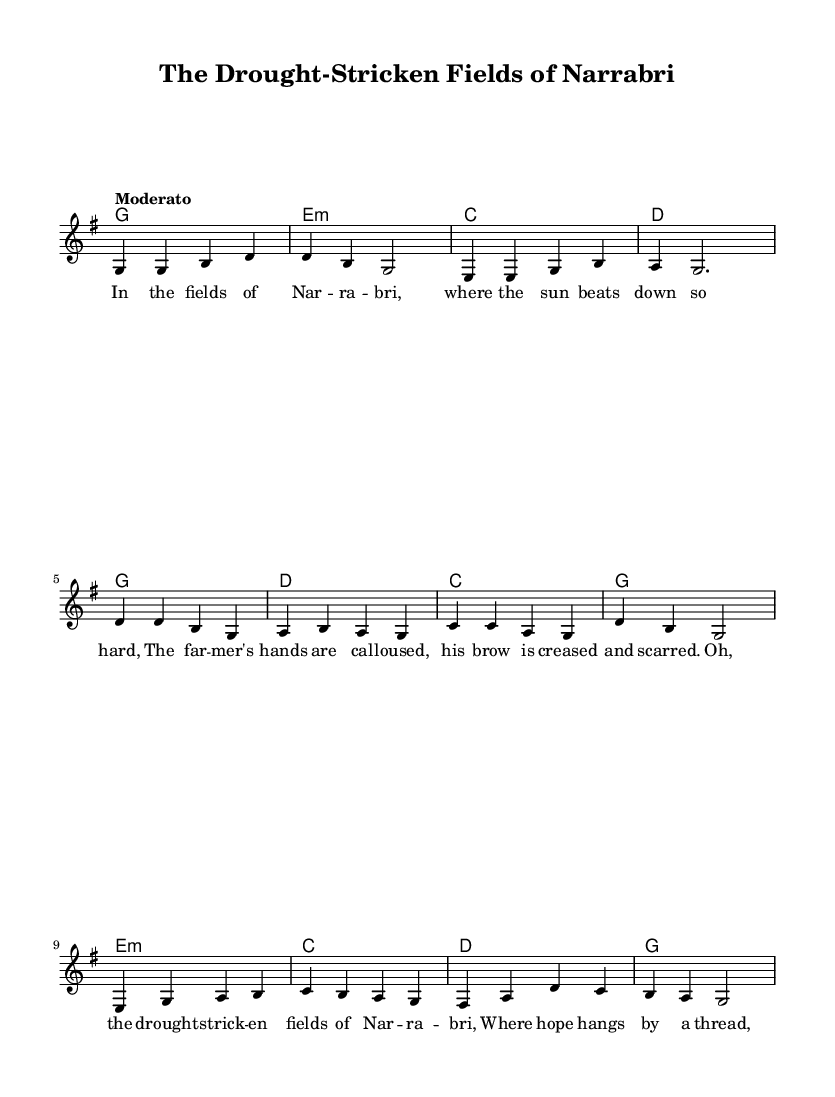What is the key signature of this music? The key signature is G major, which has one sharp (F#). This can be determined by looking at the signature markers at the start of the staff that indicate G major.
Answer: G major What is the time signature of this music? The time signature is 4/4, which is indicated at the beginning of the score. This means there are four beats in each measure and the quarter note gets one beat.
Answer: 4/4 What is the tempo marking of this music? The tempo is marked as "Moderato," which means moderately, suggesting a moderate pace in the performance of the piece. The tempo marking is typically found above the staff at the beginning of the score.
Answer: Moderato How many verses are there in the song? The song has one verse as shown in the format of the music sheet. It is followed by the chorus and a bridge, but only one verse is present within the lyrics.
Answer: One What is the starting note of the melody? The starting note of the melody is G, which is the first note indicated in the melody section of the score. This is identifiable in the melodic line at the beginning.
Answer: G Which chord is used in the chorus? The chorus begins with a G major chord, which can be seen in the chord progressions placed above the corresponding melody notes during the chorus section.
Answer: G 